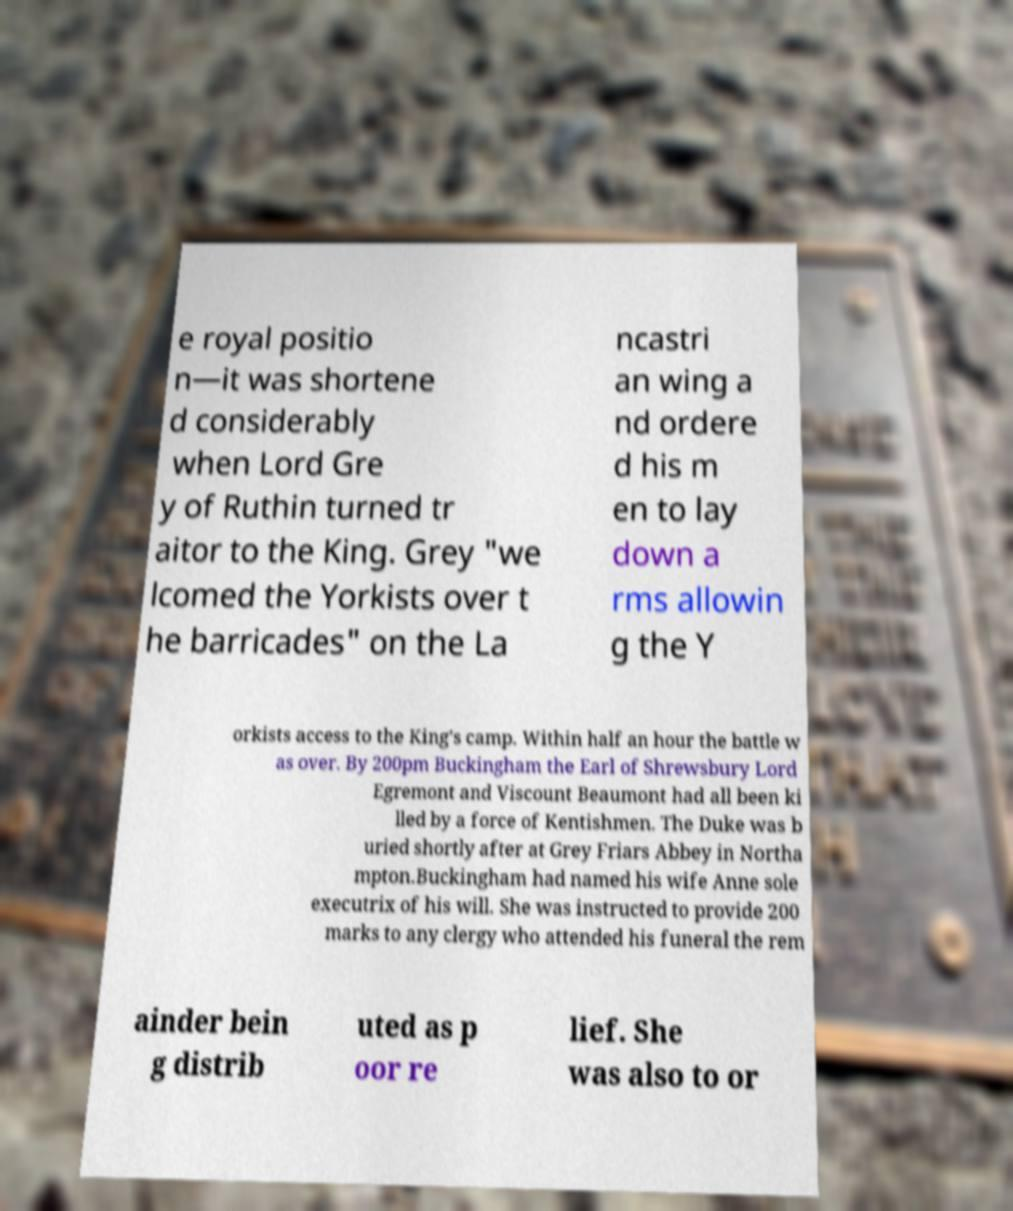For documentation purposes, I need the text within this image transcribed. Could you provide that? e royal positio n—it was shortene d considerably when Lord Gre y of Ruthin turned tr aitor to the King. Grey "we lcomed the Yorkists over t he barricades" on the La ncastri an wing a nd ordere d his m en to lay down a rms allowin g the Y orkists access to the King's camp. Within half an hour the battle w as over. By 200pm Buckingham the Earl of Shrewsbury Lord Egremont and Viscount Beaumont had all been ki lled by a force of Kentishmen. The Duke was b uried shortly after at Grey Friars Abbey in Northa mpton.Buckingham had named his wife Anne sole executrix of his will. She was instructed to provide 200 marks to any clergy who attended his funeral the rem ainder bein g distrib uted as p oor re lief. She was also to or 